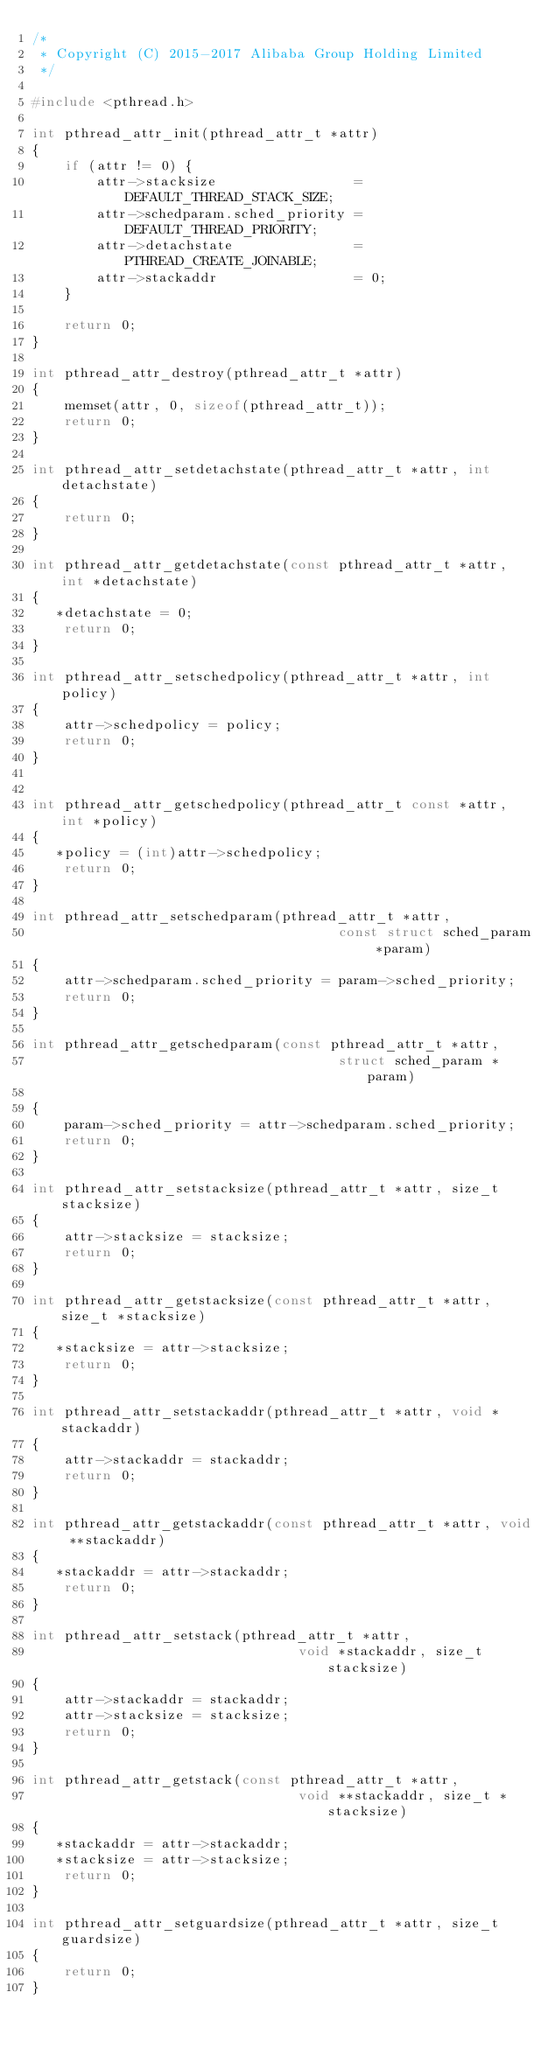<code> <loc_0><loc_0><loc_500><loc_500><_C_>/*
 * Copyright (C) 2015-2017 Alibaba Group Holding Limited
 */

#include <pthread.h>

int pthread_attr_init(pthread_attr_t *attr)
{
    if (attr != 0) {
        attr->stacksize                 = DEFAULT_THREAD_STACK_SIZE;
        attr->schedparam.sched_priority = DEFAULT_THREAD_PRIORITY;
        attr->detachstate               = PTHREAD_CREATE_JOINABLE;
        attr->stackaddr                 = 0;
    }

    return 0;
}

int pthread_attr_destroy(pthread_attr_t *attr)
{
    memset(attr, 0, sizeof(pthread_attr_t));
    return 0;
}

int pthread_attr_setdetachstate(pthread_attr_t *attr, int detachstate)
{
    return 0;
}

int pthread_attr_getdetachstate(const pthread_attr_t *attr, int *detachstate)
{
   *detachstate = 0;
    return 0;
}

int pthread_attr_setschedpolicy(pthread_attr_t *attr, int policy)
{
    attr->schedpolicy = policy;
    return 0;
}


int pthread_attr_getschedpolicy(pthread_attr_t const *attr, int *policy)
{
   *policy = (int)attr->schedpolicy;
    return 0;
}

int pthread_attr_setschedparam(pthread_attr_t *attr,
                                      const struct sched_param *param)
{
    attr->schedparam.sched_priority = param->sched_priority;
    return 0;
}

int pthread_attr_getschedparam(const pthread_attr_t *attr,
                                      struct sched_param *param)

{
    param->sched_priority = attr->schedparam.sched_priority;
    return 0;
}

int pthread_attr_setstacksize(pthread_attr_t *attr, size_t stacksize)
{
    attr->stacksize = stacksize;
    return 0;
}

int pthread_attr_getstacksize(const pthread_attr_t *attr, size_t *stacksize)
{
   *stacksize = attr->stacksize;
    return 0;
}

int pthread_attr_setstackaddr(pthread_attr_t *attr, void *stackaddr)
{
    attr->stackaddr = stackaddr;
    return 0;
}

int pthread_attr_getstackaddr(const pthread_attr_t *attr, void **stackaddr)
{
   *stackaddr = attr->stackaddr;
    return 0;
}

int pthread_attr_setstack(pthread_attr_t *attr,
                                 void *stackaddr, size_t stacksize)
{
    attr->stackaddr = stackaddr;
    attr->stacksize = stacksize;
    return 0;
}

int pthread_attr_getstack(const pthread_attr_t *attr,
                                 void **stackaddr, size_t *stacksize)
{
   *stackaddr = attr->stackaddr;
   *stacksize = attr->stacksize;
    return 0;
}

int pthread_attr_setguardsize(pthread_attr_t *attr, size_t guardsize)
{
    return 0;
}
</code> 